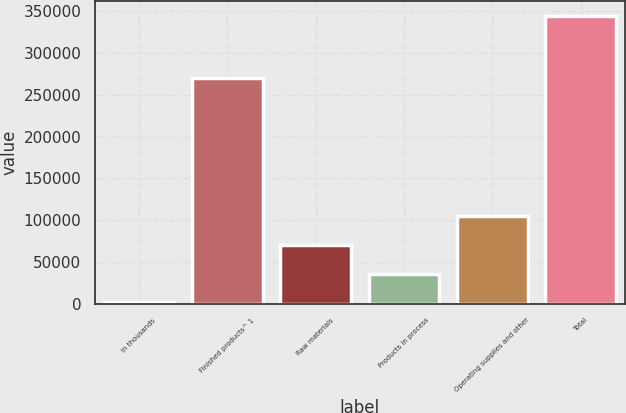Convert chart. <chart><loc_0><loc_0><loc_500><loc_500><bar_chart><fcel>in thousands<fcel>Finished products^ 1<fcel>Raw materials<fcel>Products in process<fcel>Operating supplies and other<fcel>Total<nl><fcel>2013<fcel>270603<fcel>70531.6<fcel>36272.3<fcel>104791<fcel>344606<nl></chart> 